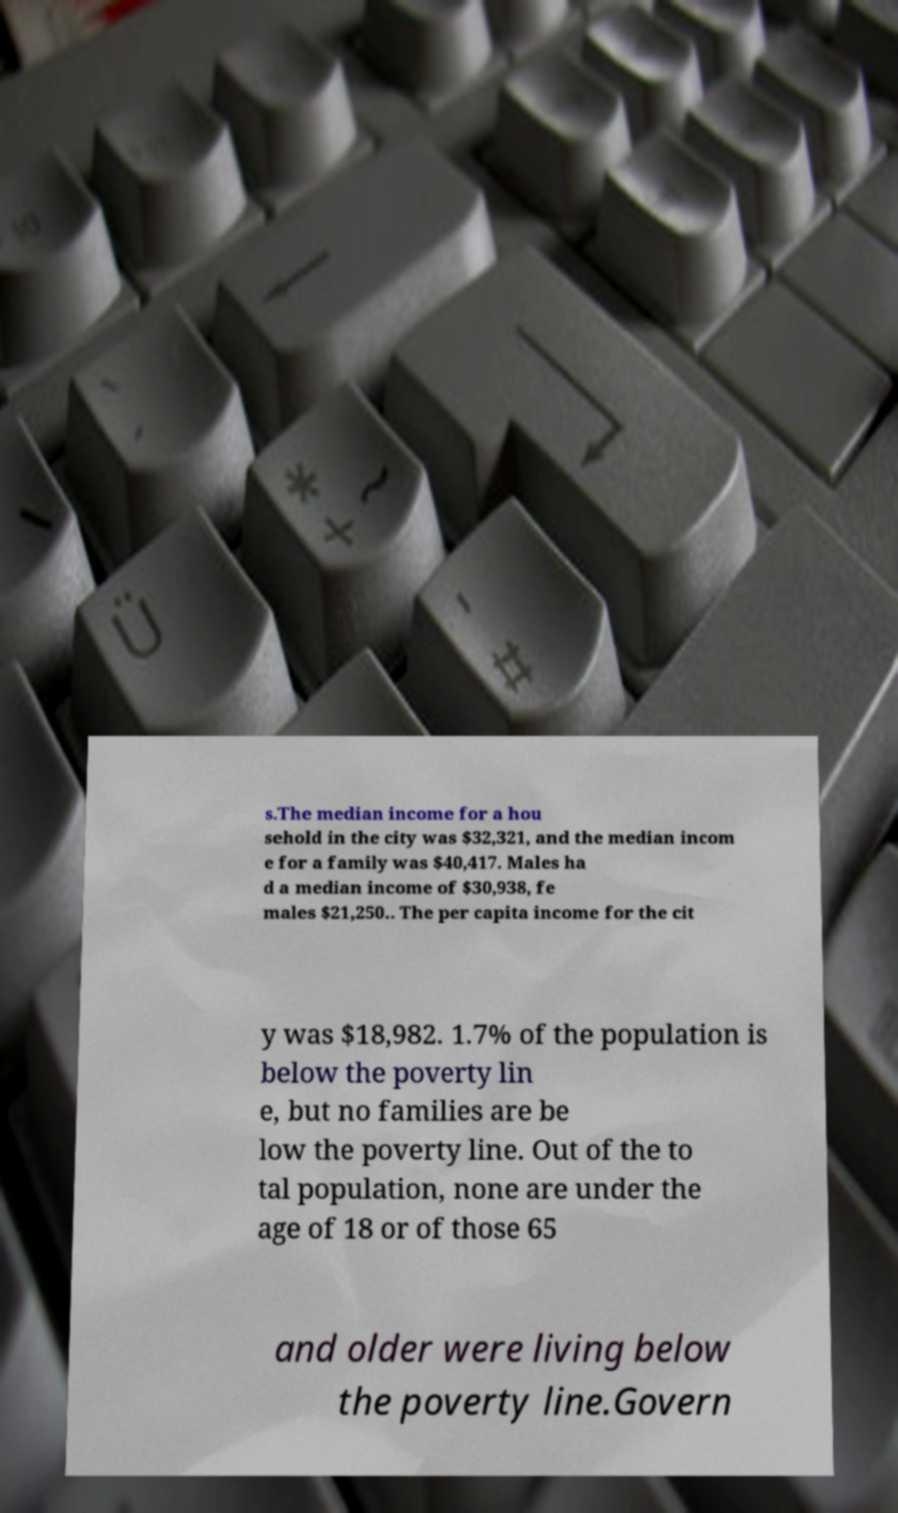Could you assist in decoding the text presented in this image and type it out clearly? s.The median income for a hou sehold in the city was $32,321, and the median incom e for a family was $40,417. Males ha d a median income of $30,938, fe males $21,250.. The per capita income for the cit y was $18,982. 1.7% of the population is below the poverty lin e, but no families are be low the poverty line. Out of the to tal population, none are under the age of 18 or of those 65 and older were living below the poverty line.Govern 